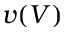<formula> <loc_0><loc_0><loc_500><loc_500>v ( V )</formula> 